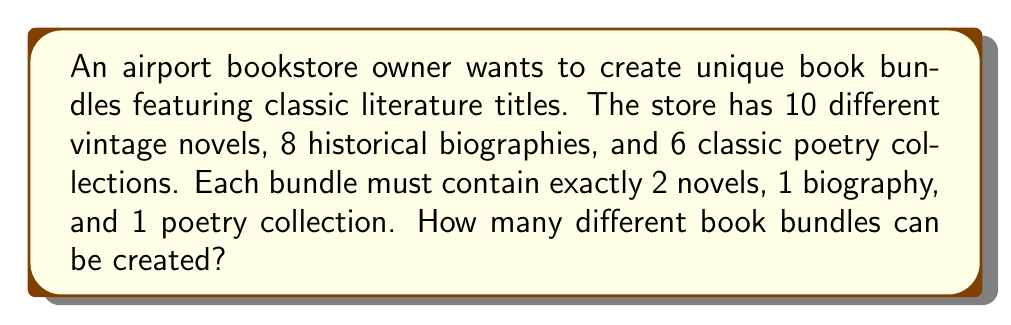Can you solve this math problem? Let's break this down step-by-step:

1. For the novels:
   - We need to choose 2 novels out of 10.
   - This is a combination problem, denoted as $\binom{10}{2}$.
   - $\binom{10}{2} = \frac{10!}{2!(10-2)!} = \frac{10!}{2!8!} = 45$

2. For the biographies:
   - We need to choose 1 biography out of 8.
   - This is simply $\binom{8}{1} = 8$

3. For the poetry collections:
   - We need to choose 1 poetry collection out of 6.
   - This is $\binom{6}{1} = 6$

4. To get the total number of unique bundles, we multiply these choices together:
   $$45 \times 8 \times 6 = 2,160$$

This multiplication is based on the Fundamental Counting Principle, which states that if we have $m$ ways of doing something and $n$ ways of doing another thing, there are $m \times n$ ways of doing both.
Answer: 2,160 unique book bundles 